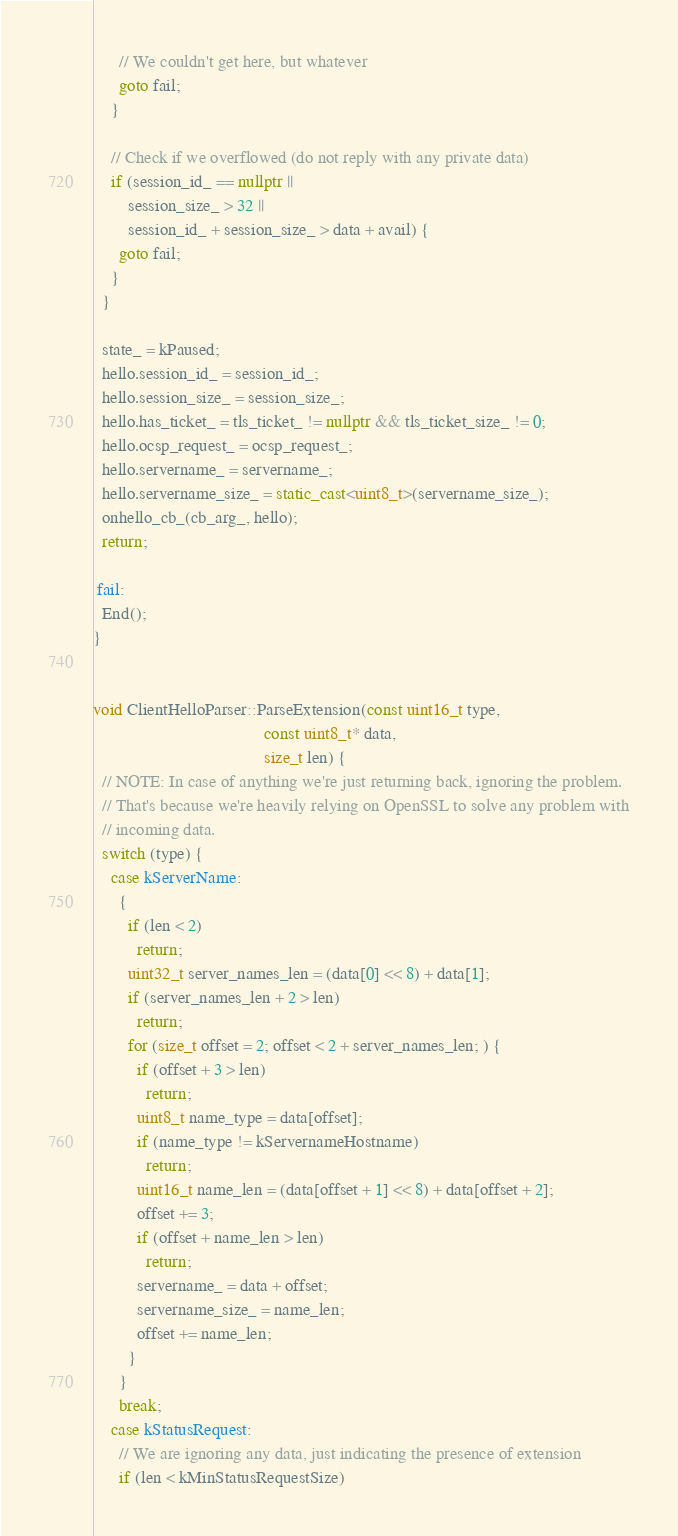<code> <loc_0><loc_0><loc_500><loc_500><_C++_>      // We couldn't get here, but whatever
      goto fail;
    }

    // Check if we overflowed (do not reply with any private data)
    if (session_id_ == nullptr ||
        session_size_ > 32 ||
        session_id_ + session_size_ > data + avail) {
      goto fail;
    }
  }

  state_ = kPaused;
  hello.session_id_ = session_id_;
  hello.session_size_ = session_size_;
  hello.has_ticket_ = tls_ticket_ != nullptr && tls_ticket_size_ != 0;
  hello.ocsp_request_ = ocsp_request_;
  hello.servername_ = servername_;
  hello.servername_size_ = static_cast<uint8_t>(servername_size_);
  onhello_cb_(cb_arg_, hello);
  return;

 fail:
  End();
}


void ClientHelloParser::ParseExtension(const uint16_t type,
                                       const uint8_t* data,
                                       size_t len) {
  // NOTE: In case of anything we're just returning back, ignoring the problem.
  // That's because we're heavily relying on OpenSSL to solve any problem with
  // incoming data.
  switch (type) {
    case kServerName:
      {
        if (len < 2)
          return;
        uint32_t server_names_len = (data[0] << 8) + data[1];
        if (server_names_len + 2 > len)
          return;
        for (size_t offset = 2; offset < 2 + server_names_len; ) {
          if (offset + 3 > len)
            return;
          uint8_t name_type = data[offset];
          if (name_type != kServernameHostname)
            return;
          uint16_t name_len = (data[offset + 1] << 8) + data[offset + 2];
          offset += 3;
          if (offset + name_len > len)
            return;
          servername_ = data + offset;
          servername_size_ = name_len;
          offset += name_len;
        }
      }
      break;
    case kStatusRequest:
      // We are ignoring any data, just indicating the presence of extension
      if (len < kMinStatusRequestSize)</code> 